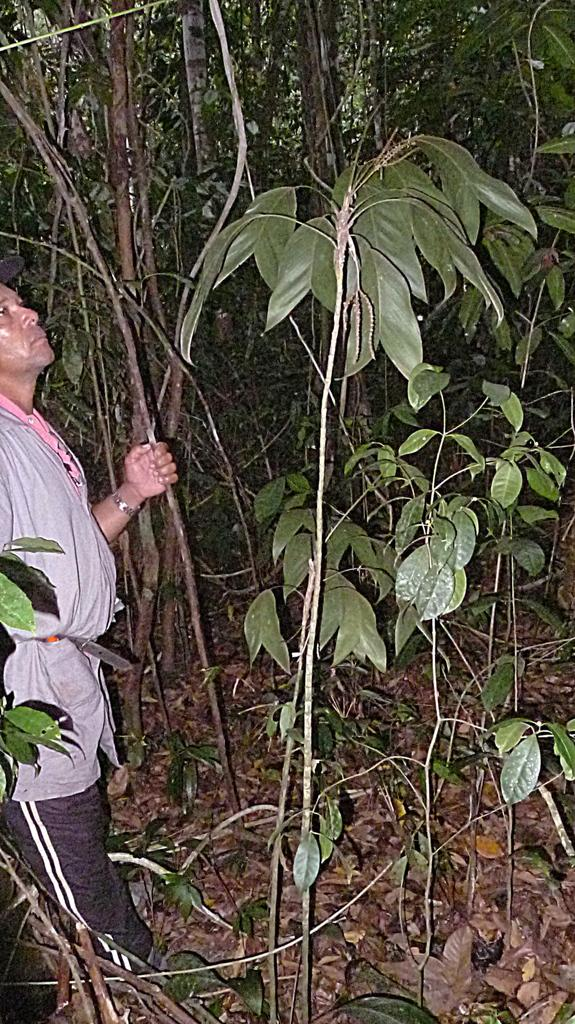What is the main subject of the image? There is a man standing in the image. What is the man wearing? The man is wearing a grey dress and black pants. What can be seen in the background of the image? There are trees visible in the image. What is the man's interest in tax policies in the image? There is no information about the man's interest in tax policies in the image. 